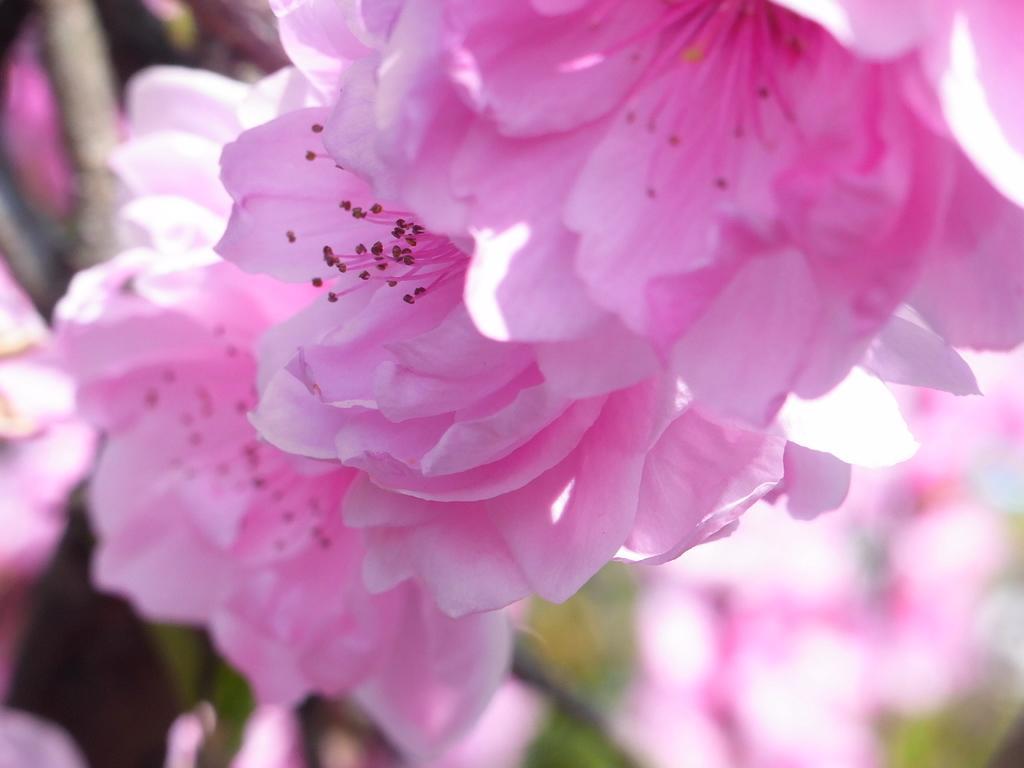In one or two sentences, can you explain what this image depicts? In this image I can see pink color flowers and plants. This image is taken may be in a garden. 